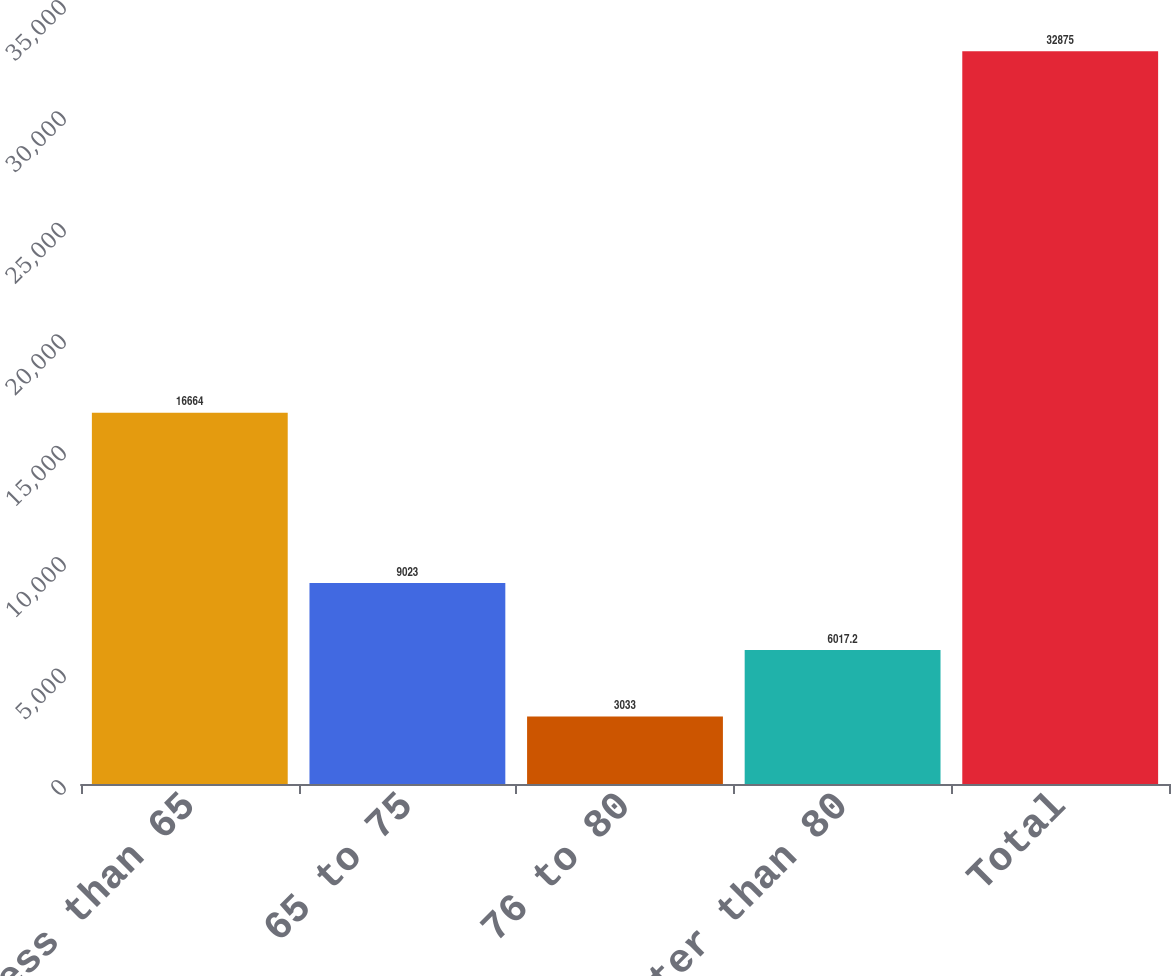Convert chart to OTSL. <chart><loc_0><loc_0><loc_500><loc_500><bar_chart><fcel>Less than 65<fcel>65 to 75<fcel>76 to 80<fcel>Greater than 80<fcel>Total<nl><fcel>16664<fcel>9023<fcel>3033<fcel>6017.2<fcel>32875<nl></chart> 